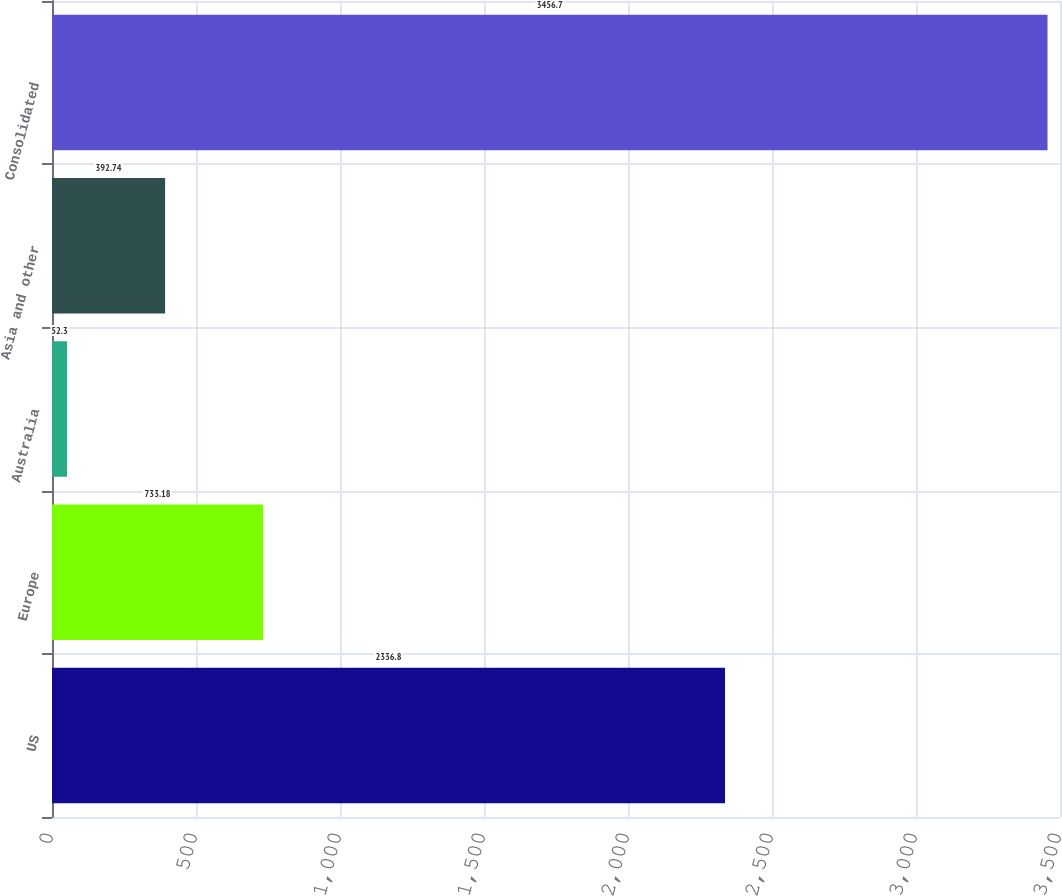Convert chart to OTSL. <chart><loc_0><loc_0><loc_500><loc_500><bar_chart><fcel>US<fcel>Europe<fcel>Australia<fcel>Asia and other<fcel>Consolidated<nl><fcel>2336.8<fcel>733.18<fcel>52.3<fcel>392.74<fcel>3456.7<nl></chart> 